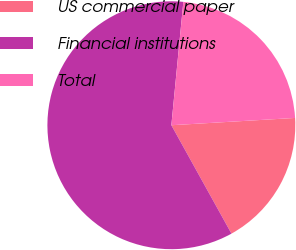Convert chart. <chart><loc_0><loc_0><loc_500><loc_500><pie_chart><fcel>US commercial paper<fcel>Financial institutions<fcel>Total<nl><fcel>17.88%<fcel>59.6%<fcel>22.52%<nl></chart> 